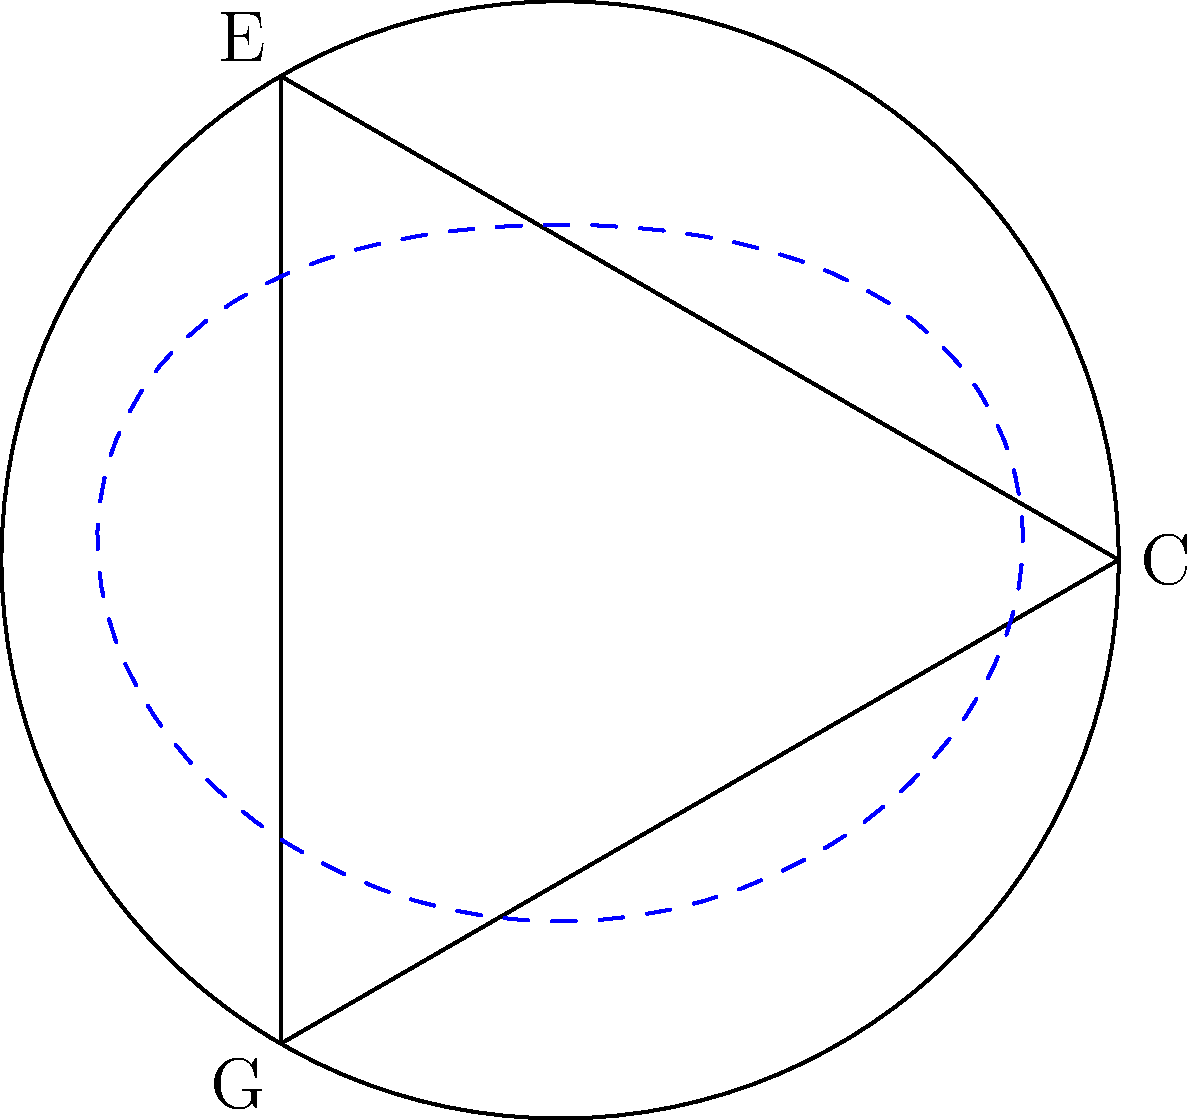Consider the space formed by interconnected musical scales, represented by the diagram above. The vertices represent the notes C, E, and G of a C major triad, and the edges represent the connections between these notes. If we define a loop $\alpha$ as shown by the dashed blue line, what is the order of $[\alpha]$ in the fundamental group of this space? To determine the order of $[\alpha]$ in the fundamental group, we need to follow these steps:

1) First, recognize that the space is homotopy equivalent to a wedge sum of two circles. This is because the triangle can be contracted to a point, leaving us with two loops.

2) The fundamental group of a wedge sum of two circles is the free group on two generators, $\pi_1(X) \cong F_2 = \langle a, b \rangle$.

3) The loop $\alpha$ can be seen as encircling both generators once. In terms of the generators, we can write $[\alpha] = ab$.

4) In a free group, the element $ab$ has infinite order. This is because no power of $ab$ can be reduced to the identity element.

5) To see this, consider $(ab)^n = abab...ab$ (n times). This word cannot be simplified further in a free group, and is distinct for each value of n.

Therefore, the order of $[\alpha]$ in the fundamental group is infinite.
Answer: Infinite 